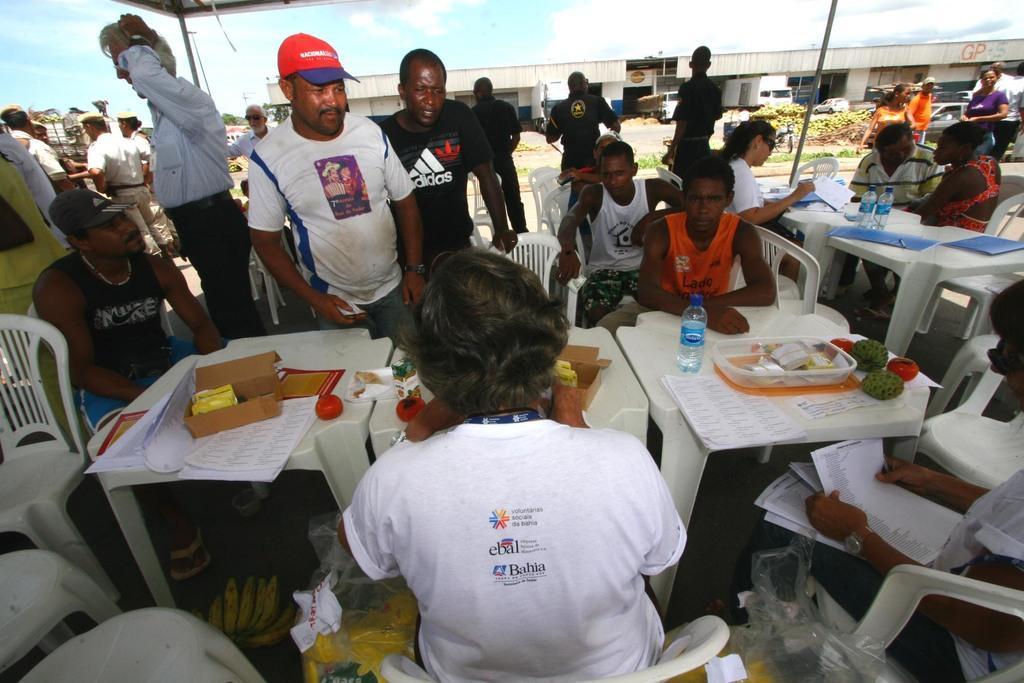Can you describe this image briefly? In this image i can see few people sitting on chairs with table in front of them and on table i can see some fruits and a water bottle, and some of the people are standing, and in the background i can see sky and some vehicles. 